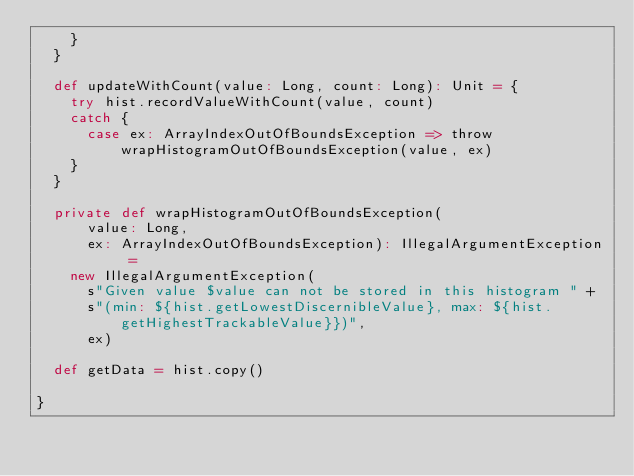<code> <loc_0><loc_0><loc_500><loc_500><_Scala_>    }
  }

  def updateWithCount(value: Long, count: Long): Unit = {
    try hist.recordValueWithCount(value, count)
    catch {
      case ex: ArrayIndexOutOfBoundsException => throw wrapHistogramOutOfBoundsException(value, ex)
    }
  }

  private def wrapHistogramOutOfBoundsException(
      value: Long,
      ex: ArrayIndexOutOfBoundsException): IllegalArgumentException =
    new IllegalArgumentException(
      s"Given value $value can not be stored in this histogram " +
      s"(min: ${hist.getLowestDiscernibleValue}, max: ${hist.getHighestTrackableValue}})",
      ex)

  def getData = hist.copy()

}
</code> 